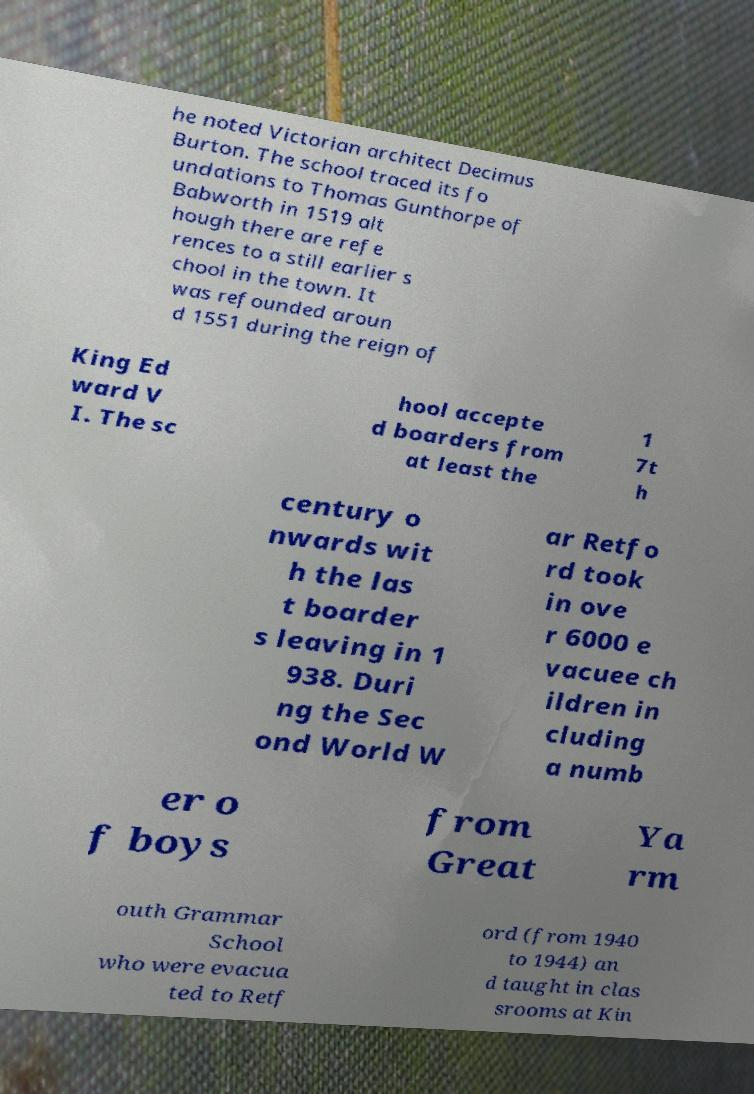Could you assist in decoding the text presented in this image and type it out clearly? he noted Victorian architect Decimus Burton. The school traced its fo undations to Thomas Gunthorpe of Babworth in 1519 alt hough there are refe rences to a still earlier s chool in the town. It was refounded aroun d 1551 during the reign of King Ed ward V I. The sc hool accepte d boarders from at least the 1 7t h century o nwards wit h the las t boarder s leaving in 1 938. Duri ng the Sec ond World W ar Retfo rd took in ove r 6000 e vacuee ch ildren in cluding a numb er o f boys from Great Ya rm outh Grammar School who were evacua ted to Retf ord (from 1940 to 1944) an d taught in clas srooms at Kin 